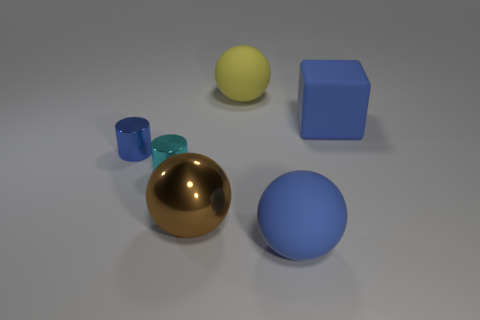If this were a still life photo, what mood or atmosphere would it convey? The composition presents a calm and minimalist atmosphere with a neutral background that puts the focus on the simplicity and beauty of the geometric shapes and their colors. The subdued lighting adds to the serene and modern feel of the scene. 